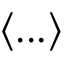<formula> <loc_0><loc_0><loc_500><loc_500>\langle \dots \rangle</formula> 